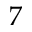Convert formula to latex. <formula><loc_0><loc_0><loc_500><loc_500>7</formula> 